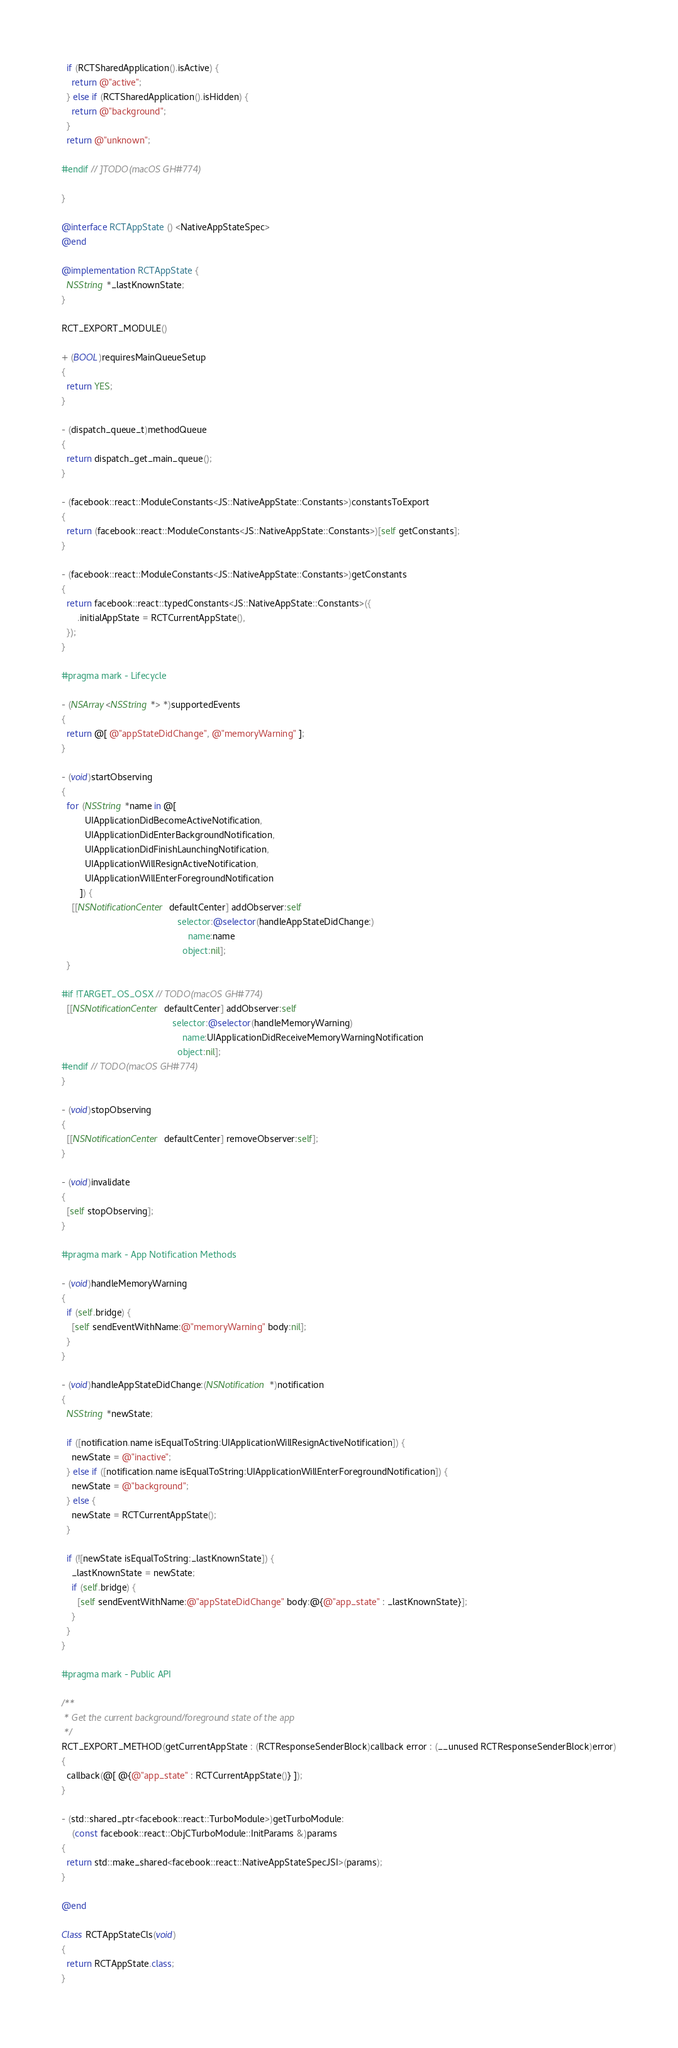Convert code to text. <code><loc_0><loc_0><loc_500><loc_500><_ObjectiveC_>  if (RCTSharedApplication().isActive) {
    return @"active";
  } else if (RCTSharedApplication().isHidden) {
    return @"background";
  }
  return @"unknown";
  
#endif // ]TODO(macOS GH#774)
  
}

@interface RCTAppState () <NativeAppStateSpec>
@end

@implementation RCTAppState {
  NSString *_lastKnownState;
}

RCT_EXPORT_MODULE()

+ (BOOL)requiresMainQueueSetup
{
  return YES;
}

- (dispatch_queue_t)methodQueue
{
  return dispatch_get_main_queue();
}

- (facebook::react::ModuleConstants<JS::NativeAppState::Constants>)constantsToExport
{
  return (facebook::react::ModuleConstants<JS::NativeAppState::Constants>)[self getConstants];
}

- (facebook::react::ModuleConstants<JS::NativeAppState::Constants>)getConstants
{
  return facebook::react::typedConstants<JS::NativeAppState::Constants>({
      .initialAppState = RCTCurrentAppState(),
  });
}

#pragma mark - Lifecycle

- (NSArray<NSString *> *)supportedEvents
{
  return @[ @"appStateDidChange", @"memoryWarning" ];
}

- (void)startObserving
{
  for (NSString *name in @[
         UIApplicationDidBecomeActiveNotification,
         UIApplicationDidEnterBackgroundNotification,
         UIApplicationDidFinishLaunchingNotification,
         UIApplicationWillResignActiveNotification,
         UIApplicationWillEnterForegroundNotification
       ]) {
    [[NSNotificationCenter defaultCenter] addObserver:self
                                             selector:@selector(handleAppStateDidChange:)
                                                 name:name
                                               object:nil];
  }

#if !TARGET_OS_OSX // TODO(macOS GH#774)
  [[NSNotificationCenter defaultCenter] addObserver:self
                                           selector:@selector(handleMemoryWarning)
                                               name:UIApplicationDidReceiveMemoryWarningNotification
                                             object:nil];
#endif // TODO(macOS GH#774)
}

- (void)stopObserving
{
  [[NSNotificationCenter defaultCenter] removeObserver:self];
}

- (void)invalidate
{
  [self stopObserving];
}

#pragma mark - App Notification Methods

- (void)handleMemoryWarning
{
  if (self.bridge) {
    [self sendEventWithName:@"memoryWarning" body:nil];
  }
}

- (void)handleAppStateDidChange:(NSNotification *)notification
{
  NSString *newState;

  if ([notification.name isEqualToString:UIApplicationWillResignActiveNotification]) {
    newState = @"inactive";
  } else if ([notification.name isEqualToString:UIApplicationWillEnterForegroundNotification]) {
    newState = @"background";
  } else {
    newState = RCTCurrentAppState();
  }

  if (![newState isEqualToString:_lastKnownState]) {
    _lastKnownState = newState;
    if (self.bridge) {
      [self sendEventWithName:@"appStateDidChange" body:@{@"app_state" : _lastKnownState}];
    }
  }
}

#pragma mark - Public API

/**
 * Get the current background/foreground state of the app
 */
RCT_EXPORT_METHOD(getCurrentAppState : (RCTResponseSenderBlock)callback error : (__unused RCTResponseSenderBlock)error)
{
  callback(@[ @{@"app_state" : RCTCurrentAppState()} ]);
}

- (std::shared_ptr<facebook::react::TurboModule>)getTurboModule:
    (const facebook::react::ObjCTurboModule::InitParams &)params
{
  return std::make_shared<facebook::react::NativeAppStateSpecJSI>(params);
}

@end

Class RCTAppStateCls(void)
{
  return RCTAppState.class;
}
</code> 